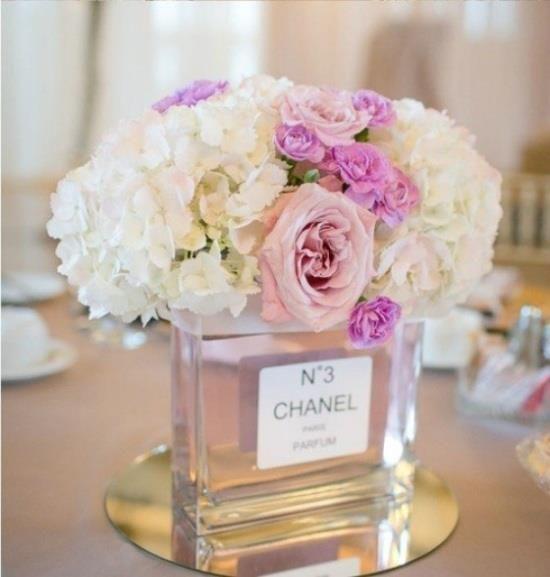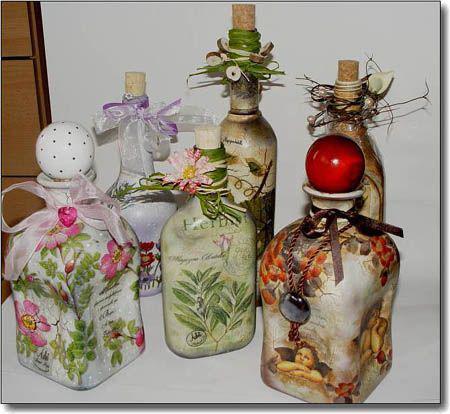The first image is the image on the left, the second image is the image on the right. Analyze the images presented: Is the assertion "There are two containers in one of the images." valid? Answer yes or no. No. The first image is the image on the left, the second image is the image on the right. For the images shown, is this caption "An image shows at least two decorative bottles flanked by flowers, and the bottles feature different metallic colors partly wrapping semi-translucent glass." true? Answer yes or no. No. 